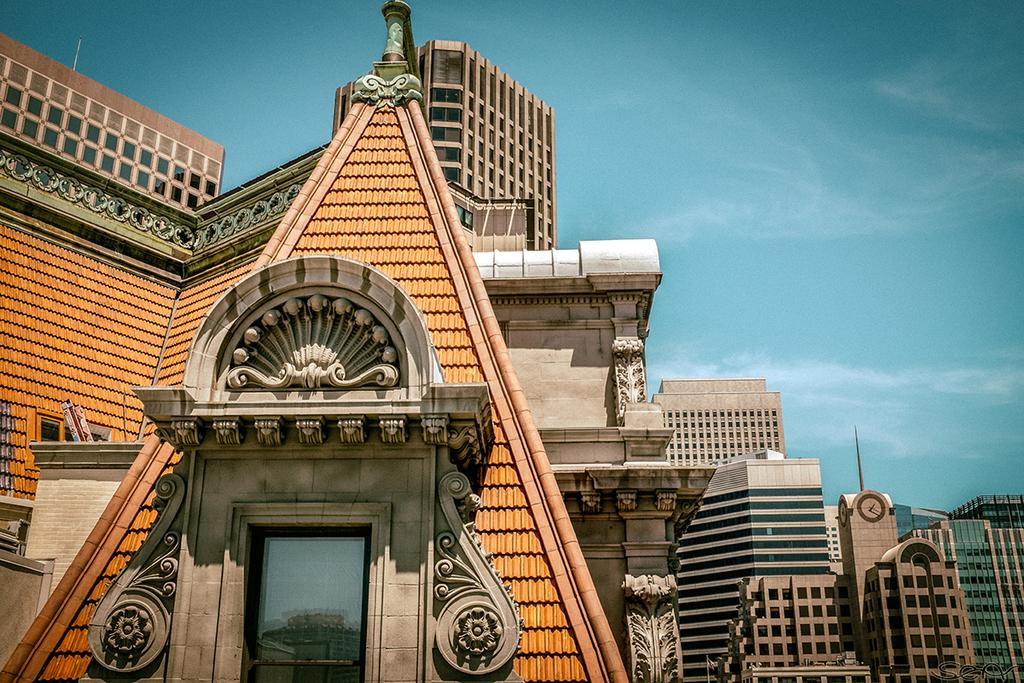What type of structures are visible in the image? There are buildings with windows in the image. What part of the natural environment is visible in the image? The sky is visible in the image. How would you describe the sky in the image? The sky appears to be cloudy. What flavor of control can be seen in the image? There is no control present in the image, and therefore no flavor can be associated with it. 